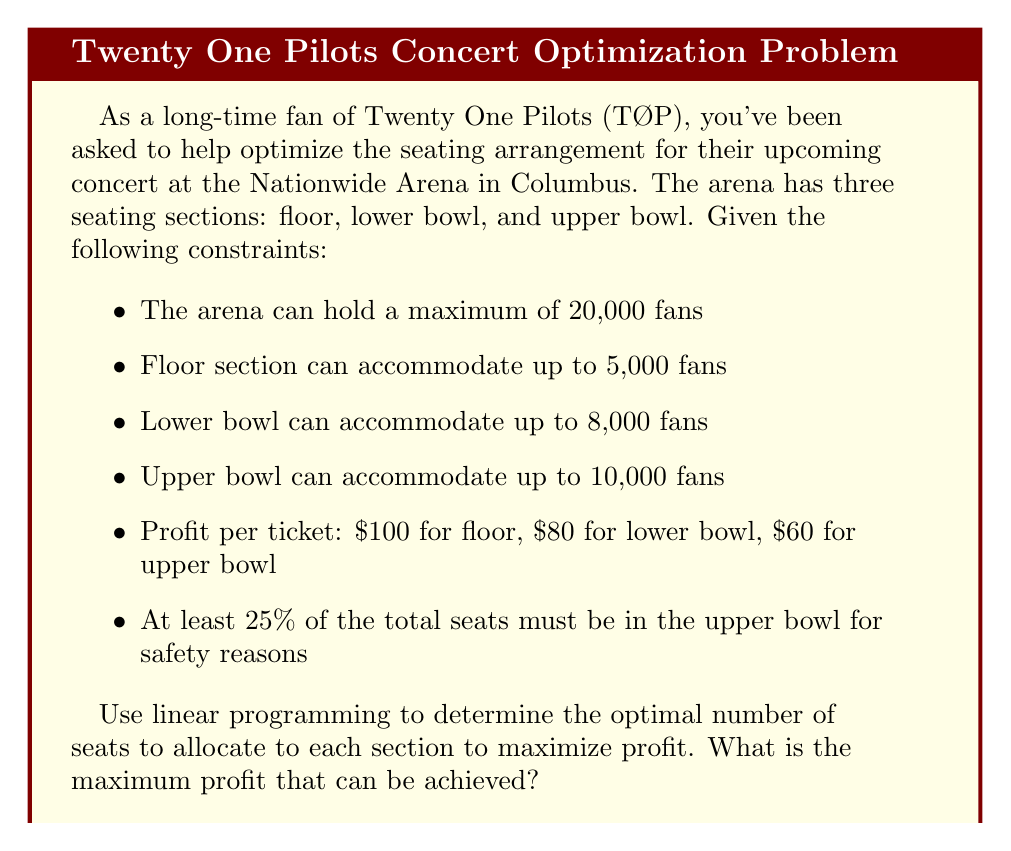Can you answer this question? Let's approach this step-by-step using linear programming:

1) Define variables:
   Let $x$ = number of floor seats
   Let $y$ = number of lower bowl seats
   Let $z$ = number of upper bowl seats

2) Objective function (maximize profit):
   $$ \text{Maximize } P = 100x + 80y + 60z $$

3) Constraints:
   a) Total capacity: $x + y + z \leq 20000$
   b) Floor capacity: $x \leq 5000$
   c) Lower bowl capacity: $y \leq 8000$
   d) Upper bowl capacity: $z \leq 10000$
   e) Upper bowl minimum requirement: $z \geq 0.25(x + y + z)$
   f) Non-negativity: $x, y, z \geq 0$

4) Simplify the upper bowl requirement:
   $z \geq 0.25(x + y + z)$
   $0.75z \geq 0.25(x + y)$
   $3z \geq x + y$

5) Set up the linear programming problem:

   Maximize: $P = 100x + 80y + 60z$
   Subject to:
   $x + y + z \leq 20000$
   $x \leq 5000$
   $y \leq 8000$
   $z \leq 10000$
   $3z \geq x + y$
   $x, y, z \geq 0$

6) Solve using the simplex method or linear programming software.

7) The optimal solution is:
   $x = 5000$ (floor seats)
   $y = 8000$ (lower bowl seats)
   $z = 7000$ (upper bowl seats)

8) Calculate the maximum profit:
   $P = 100(5000) + 80(8000) + 60(7000) = 1,500,000$

This solution satisfies all constraints:
- Total seats: 5000 + 8000 + 7000 = 20000 ≤ 20000
- Floor seats: 5000 ≤ 5000
- Lower bowl seats: 8000 ≤ 8000
- Upper bowl seats: 7000 ≤ 10000
- Upper bowl requirement: 7000 ≥ 0.25(20000) = 5000
Answer: The maximum profit that can be achieved is $1,500,000. 